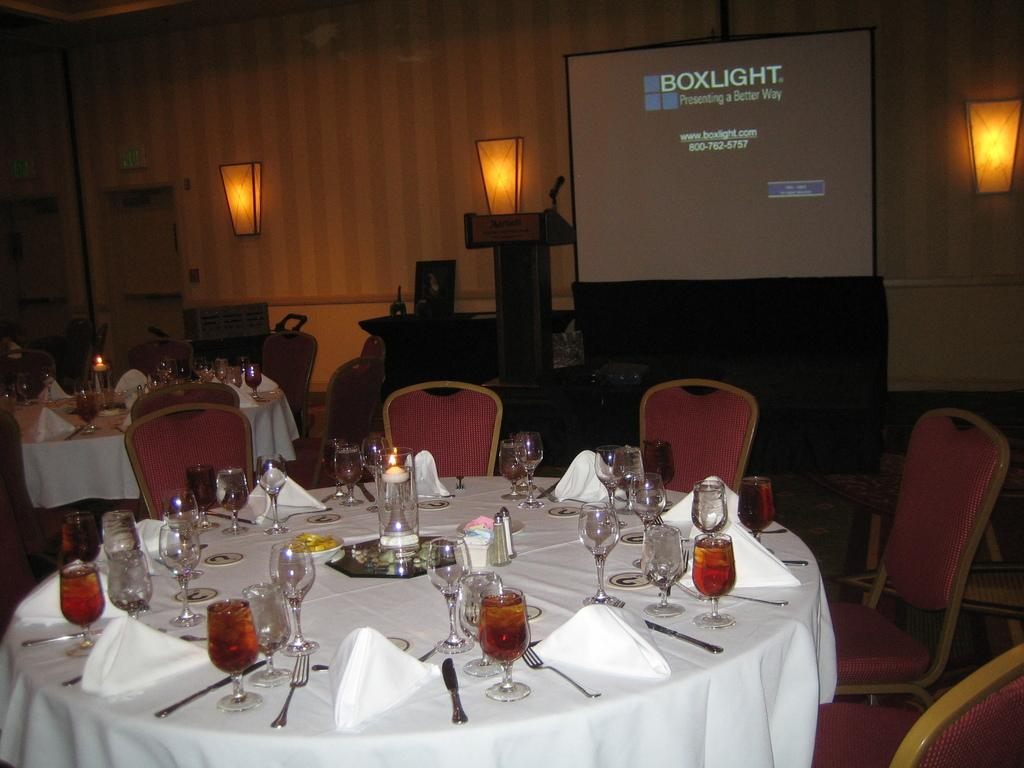Provide a one-sentence caption for the provided image. Dinner tables set up in front of a screen that says Boxlight on it. 